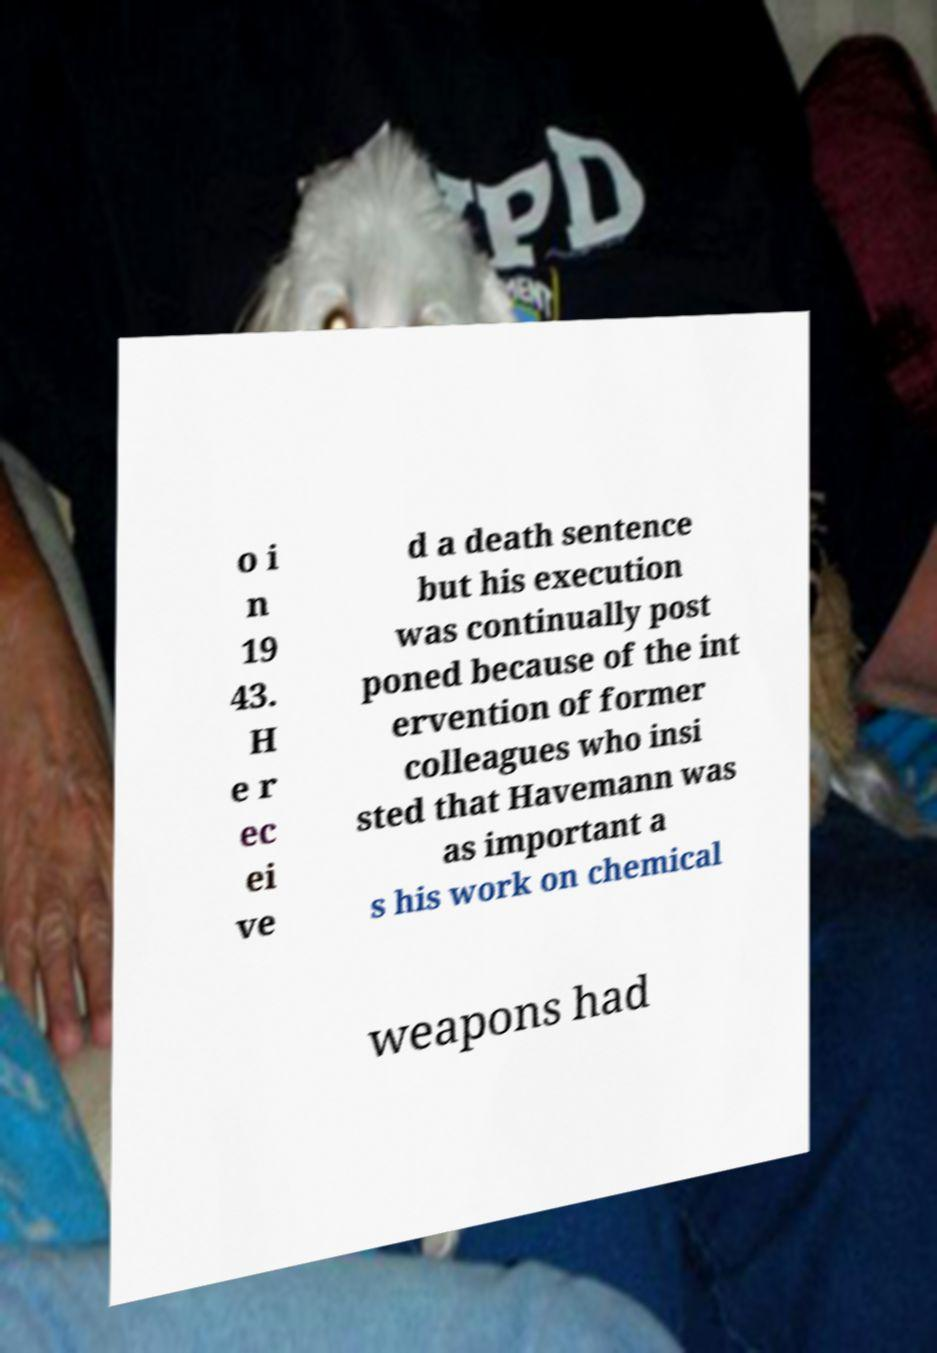Can you read and provide the text displayed in the image?This photo seems to have some interesting text. Can you extract and type it out for me? o i n 19 43. H e r ec ei ve d a death sentence but his execution was continually post poned because of the int ervention of former colleagues who insi sted that Havemann was as important a s his work on chemical weapons had 